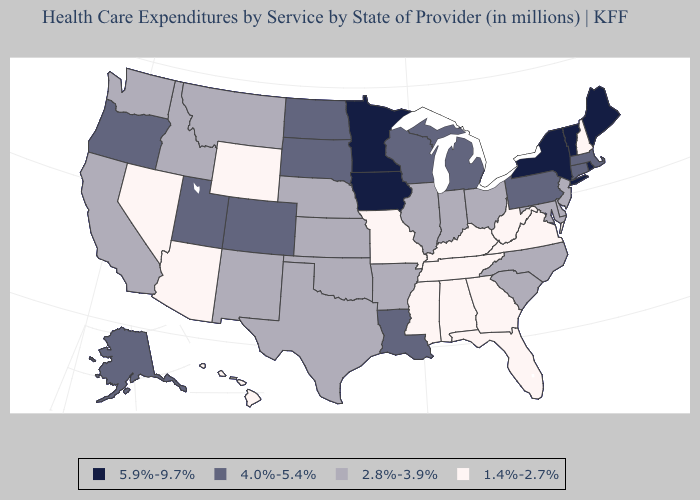What is the highest value in states that border Delaware?
Concise answer only. 4.0%-5.4%. Which states hav the highest value in the Northeast?
Concise answer only. Maine, New York, Rhode Island, Vermont. Among the states that border New Jersey , which have the lowest value?
Keep it brief. Delaware. What is the highest value in the South ?
Short answer required. 4.0%-5.4%. What is the value of Mississippi?
Be succinct. 1.4%-2.7%. Among the states that border Alabama , which have the highest value?
Quick response, please. Florida, Georgia, Mississippi, Tennessee. Name the states that have a value in the range 1.4%-2.7%?
Write a very short answer. Alabama, Arizona, Florida, Georgia, Hawaii, Kentucky, Mississippi, Missouri, Nevada, New Hampshire, Tennessee, Virginia, West Virginia, Wyoming. Name the states that have a value in the range 1.4%-2.7%?
Answer briefly. Alabama, Arizona, Florida, Georgia, Hawaii, Kentucky, Mississippi, Missouri, Nevada, New Hampshire, Tennessee, Virginia, West Virginia, Wyoming. What is the value of Arizona?
Keep it brief. 1.4%-2.7%. What is the lowest value in the South?
Write a very short answer. 1.4%-2.7%. What is the value of Massachusetts?
Give a very brief answer. 4.0%-5.4%. What is the lowest value in states that border Wisconsin?
Give a very brief answer. 2.8%-3.9%. Does Texas have a lower value than South Dakota?
Write a very short answer. Yes. Which states have the highest value in the USA?
Quick response, please. Iowa, Maine, Minnesota, New York, Rhode Island, Vermont. What is the value of Florida?
Answer briefly. 1.4%-2.7%. 